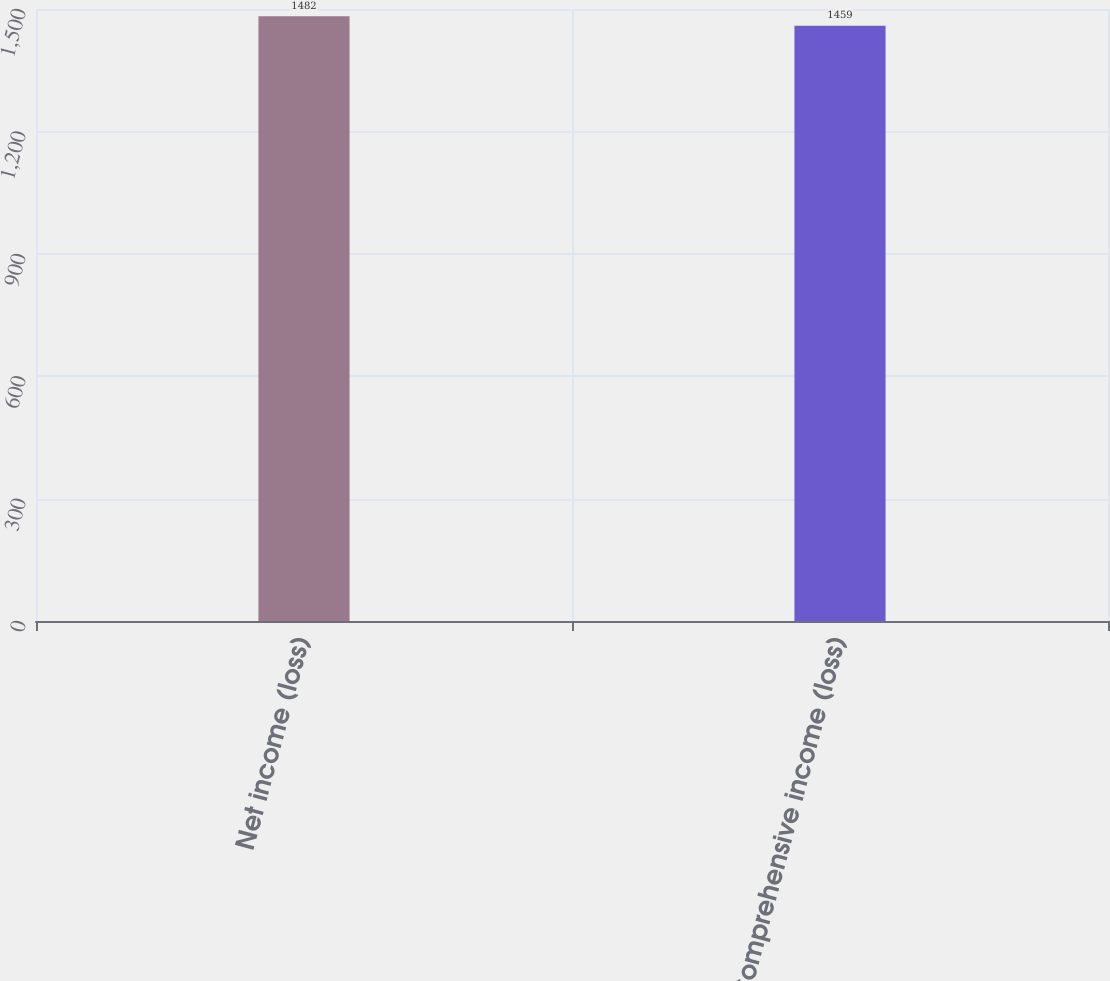<chart> <loc_0><loc_0><loc_500><loc_500><bar_chart><fcel>Net income (loss)<fcel>Comprehensive income (loss)<nl><fcel>1482<fcel>1459<nl></chart> 